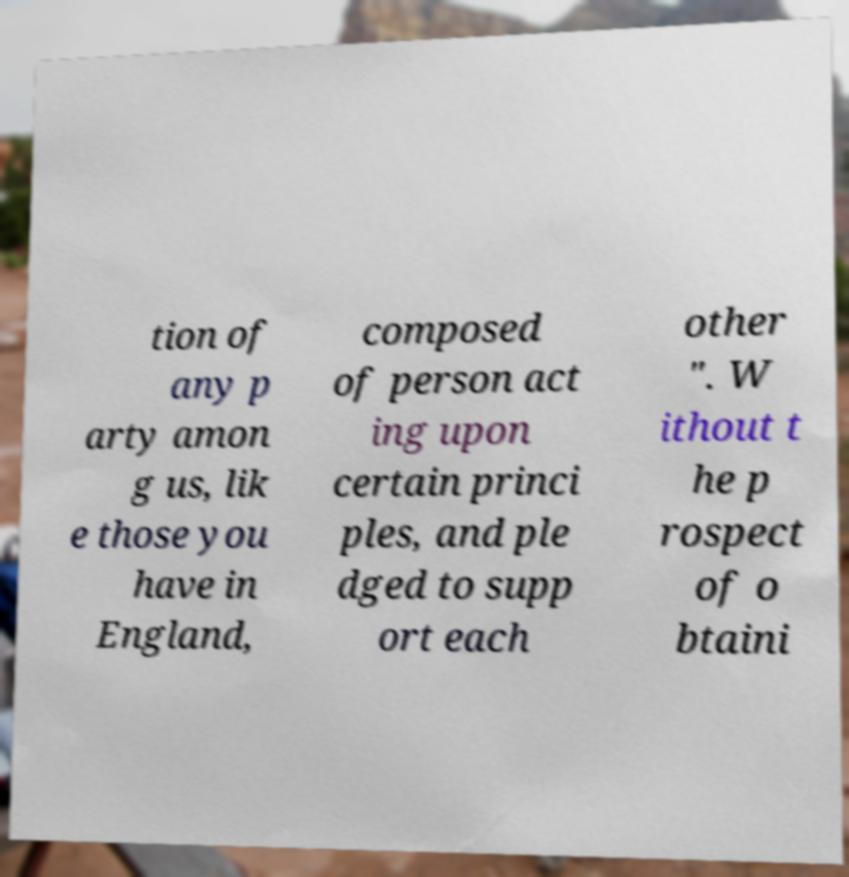For documentation purposes, I need the text within this image transcribed. Could you provide that? tion of any p arty amon g us, lik e those you have in England, composed of person act ing upon certain princi ples, and ple dged to supp ort each other ". W ithout t he p rospect of o btaini 